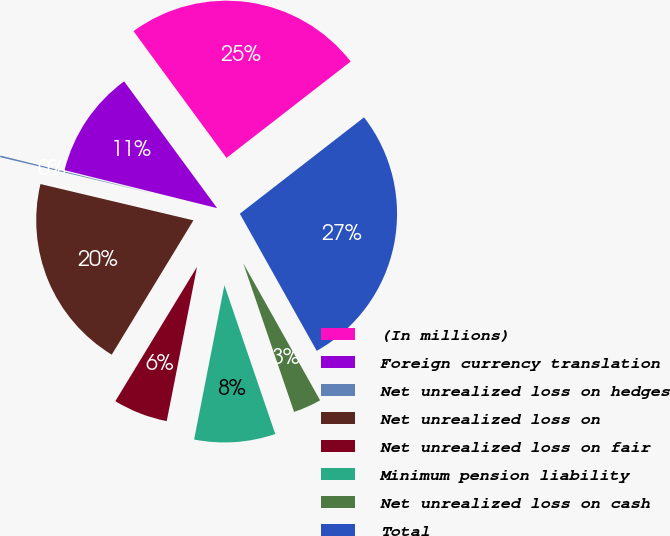<chart> <loc_0><loc_0><loc_500><loc_500><pie_chart><fcel>(In millions)<fcel>Foreign currency translation<fcel>Net unrealized loss on hedges<fcel>Net unrealized loss on<fcel>Net unrealized loss on fair<fcel>Minimum pension liability<fcel>Net unrealized loss on cash<fcel>Total<nl><fcel>24.57%<fcel>11.05%<fcel>0.17%<fcel>20.01%<fcel>5.61%<fcel>8.33%<fcel>2.89%<fcel>27.37%<nl></chart> 